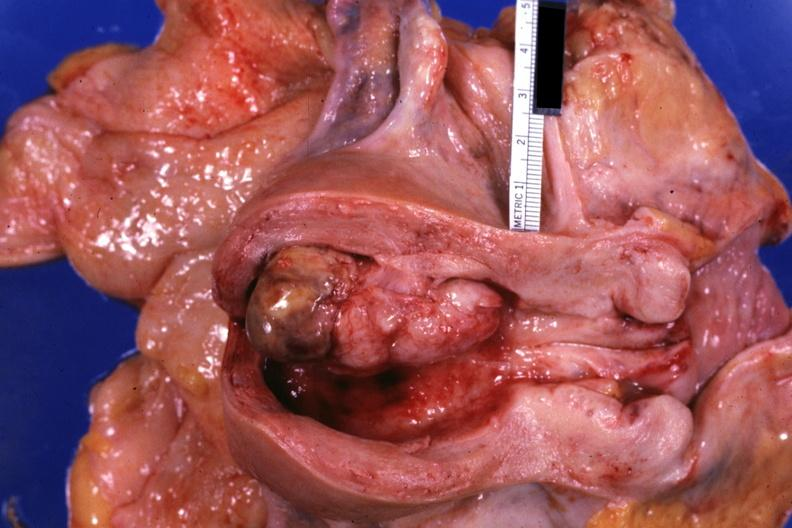s normal immature infant present?
Answer the question using a single word or phrase. No 